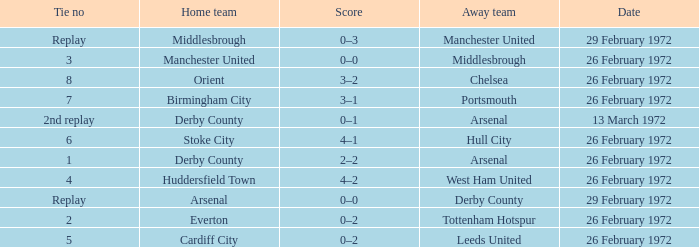Which Tie is from everton? 2.0. 